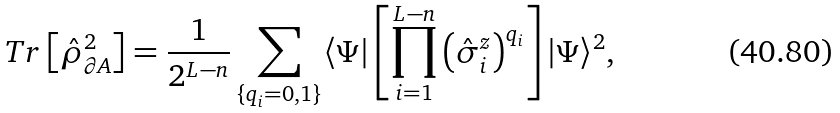Convert formula to latex. <formula><loc_0><loc_0><loc_500><loc_500>T r \left [ \hat { \rho } _ { \partial A } ^ { 2 } \right ] = \frac { 1 } { 2 ^ { L - n } } \sum _ { \{ q _ { i } = 0 , 1 \} } \langle \Psi | \left [ \prod _ { i = 1 } ^ { L - n } \left ( \hat { \sigma } _ { i } ^ { z } \right ) ^ { q _ { i } } \right ] | \Psi \rangle ^ { 2 } ,</formula> 